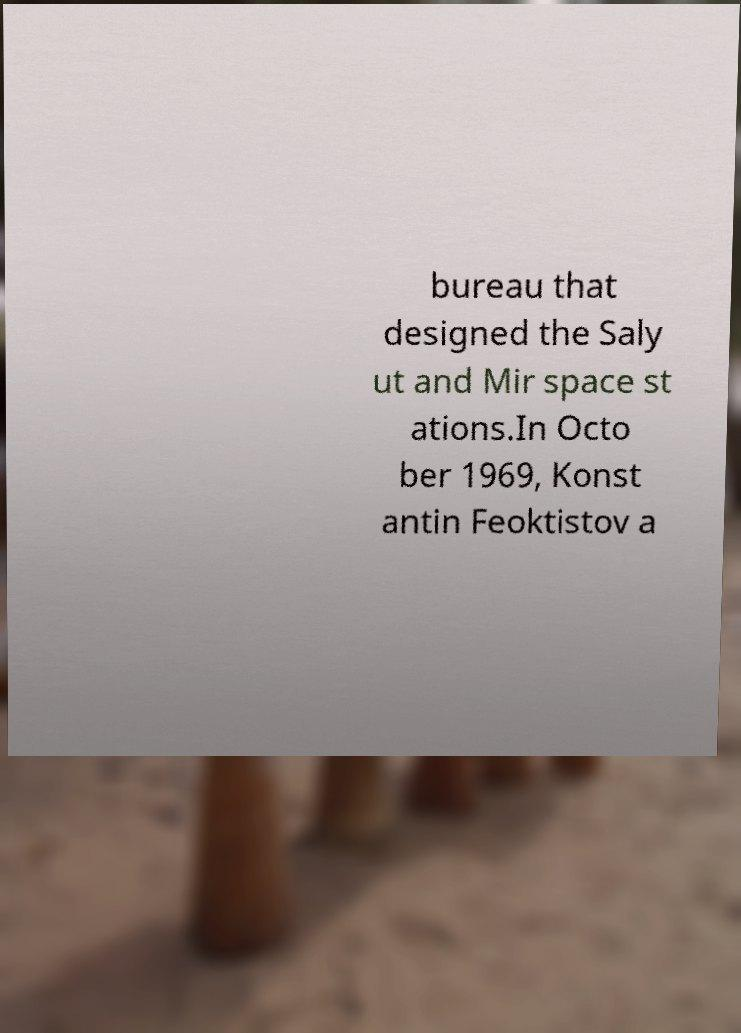Please read and relay the text visible in this image. What does it say? bureau that designed the Saly ut and Mir space st ations.In Octo ber 1969, Konst antin Feoktistov a 